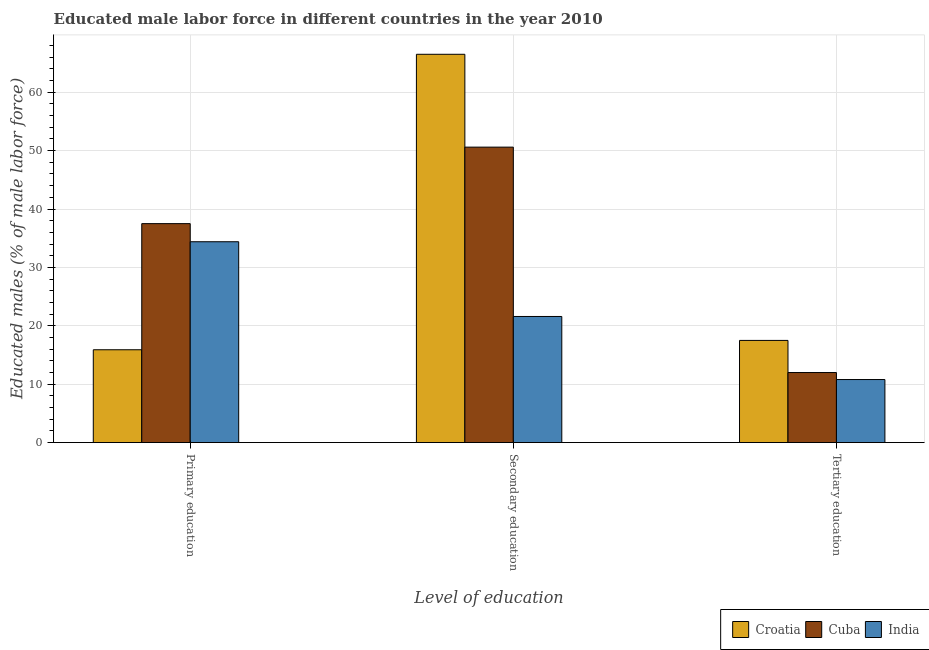How many different coloured bars are there?
Provide a short and direct response. 3. How many groups of bars are there?
Ensure brevity in your answer.  3. How many bars are there on the 2nd tick from the left?
Keep it short and to the point. 3. How many bars are there on the 3rd tick from the right?
Your answer should be compact. 3. What is the label of the 3rd group of bars from the left?
Offer a very short reply. Tertiary education. What is the percentage of male labor force who received secondary education in Cuba?
Offer a terse response. 50.6. Across all countries, what is the maximum percentage of male labor force who received secondary education?
Provide a short and direct response. 66.5. Across all countries, what is the minimum percentage of male labor force who received primary education?
Ensure brevity in your answer.  15.9. In which country was the percentage of male labor force who received tertiary education maximum?
Offer a very short reply. Croatia. In which country was the percentage of male labor force who received primary education minimum?
Your answer should be compact. Croatia. What is the total percentage of male labor force who received secondary education in the graph?
Give a very brief answer. 138.7. What is the difference between the percentage of male labor force who received secondary education in Croatia and that in Cuba?
Your response must be concise. 15.9. What is the difference between the percentage of male labor force who received primary education in India and the percentage of male labor force who received tertiary education in Croatia?
Your response must be concise. 16.9. What is the average percentage of male labor force who received primary education per country?
Make the answer very short. 29.27. What is the difference between the percentage of male labor force who received tertiary education and percentage of male labor force who received primary education in Cuba?
Offer a very short reply. -25.5. In how many countries, is the percentage of male labor force who received primary education greater than 24 %?
Offer a terse response. 2. What is the ratio of the percentage of male labor force who received secondary education in Croatia to that in India?
Your answer should be very brief. 3.08. Is the percentage of male labor force who received tertiary education in Croatia less than that in India?
Ensure brevity in your answer.  No. Is the difference between the percentage of male labor force who received secondary education in Cuba and India greater than the difference between the percentage of male labor force who received primary education in Cuba and India?
Make the answer very short. Yes. What is the difference between the highest and the second highest percentage of male labor force who received primary education?
Your answer should be very brief. 3.1. What is the difference between the highest and the lowest percentage of male labor force who received primary education?
Your answer should be compact. 21.6. Is the sum of the percentage of male labor force who received tertiary education in Cuba and India greater than the maximum percentage of male labor force who received primary education across all countries?
Offer a very short reply. No. What does the 2nd bar from the right in Primary education represents?
Provide a succinct answer. Cuba. How many bars are there?
Give a very brief answer. 9. What is the difference between two consecutive major ticks on the Y-axis?
Provide a succinct answer. 10. Does the graph contain grids?
Give a very brief answer. Yes. Where does the legend appear in the graph?
Give a very brief answer. Bottom right. How many legend labels are there?
Offer a very short reply. 3. How are the legend labels stacked?
Your answer should be very brief. Horizontal. What is the title of the graph?
Keep it short and to the point. Educated male labor force in different countries in the year 2010. What is the label or title of the X-axis?
Your response must be concise. Level of education. What is the label or title of the Y-axis?
Your answer should be very brief. Educated males (% of male labor force). What is the Educated males (% of male labor force) in Croatia in Primary education?
Give a very brief answer. 15.9. What is the Educated males (% of male labor force) in Cuba in Primary education?
Your response must be concise. 37.5. What is the Educated males (% of male labor force) of India in Primary education?
Your response must be concise. 34.4. What is the Educated males (% of male labor force) in Croatia in Secondary education?
Make the answer very short. 66.5. What is the Educated males (% of male labor force) in Cuba in Secondary education?
Provide a succinct answer. 50.6. What is the Educated males (% of male labor force) of India in Secondary education?
Provide a short and direct response. 21.6. What is the Educated males (% of male labor force) in India in Tertiary education?
Give a very brief answer. 10.8. Across all Level of education, what is the maximum Educated males (% of male labor force) of Croatia?
Your answer should be very brief. 66.5. Across all Level of education, what is the maximum Educated males (% of male labor force) in Cuba?
Make the answer very short. 50.6. Across all Level of education, what is the maximum Educated males (% of male labor force) in India?
Provide a succinct answer. 34.4. Across all Level of education, what is the minimum Educated males (% of male labor force) in Croatia?
Keep it short and to the point. 15.9. Across all Level of education, what is the minimum Educated males (% of male labor force) in Cuba?
Your answer should be very brief. 12. Across all Level of education, what is the minimum Educated males (% of male labor force) of India?
Keep it short and to the point. 10.8. What is the total Educated males (% of male labor force) of Croatia in the graph?
Your answer should be compact. 99.9. What is the total Educated males (% of male labor force) of Cuba in the graph?
Your answer should be very brief. 100.1. What is the total Educated males (% of male labor force) of India in the graph?
Your answer should be very brief. 66.8. What is the difference between the Educated males (% of male labor force) in Croatia in Primary education and that in Secondary education?
Make the answer very short. -50.6. What is the difference between the Educated males (% of male labor force) in Cuba in Primary education and that in Secondary education?
Provide a succinct answer. -13.1. What is the difference between the Educated males (% of male labor force) of Croatia in Primary education and that in Tertiary education?
Give a very brief answer. -1.6. What is the difference between the Educated males (% of male labor force) in India in Primary education and that in Tertiary education?
Offer a very short reply. 23.6. What is the difference between the Educated males (% of male labor force) in Cuba in Secondary education and that in Tertiary education?
Offer a very short reply. 38.6. What is the difference between the Educated males (% of male labor force) of Croatia in Primary education and the Educated males (% of male labor force) of Cuba in Secondary education?
Make the answer very short. -34.7. What is the difference between the Educated males (% of male labor force) in Croatia in Primary education and the Educated males (% of male labor force) in India in Tertiary education?
Offer a very short reply. 5.1. What is the difference between the Educated males (% of male labor force) in Cuba in Primary education and the Educated males (% of male labor force) in India in Tertiary education?
Give a very brief answer. 26.7. What is the difference between the Educated males (% of male labor force) of Croatia in Secondary education and the Educated males (% of male labor force) of Cuba in Tertiary education?
Offer a very short reply. 54.5. What is the difference between the Educated males (% of male labor force) of Croatia in Secondary education and the Educated males (% of male labor force) of India in Tertiary education?
Offer a terse response. 55.7. What is the difference between the Educated males (% of male labor force) of Cuba in Secondary education and the Educated males (% of male labor force) of India in Tertiary education?
Your answer should be compact. 39.8. What is the average Educated males (% of male labor force) of Croatia per Level of education?
Your answer should be very brief. 33.3. What is the average Educated males (% of male labor force) in Cuba per Level of education?
Make the answer very short. 33.37. What is the average Educated males (% of male labor force) in India per Level of education?
Your answer should be very brief. 22.27. What is the difference between the Educated males (% of male labor force) of Croatia and Educated males (% of male labor force) of Cuba in Primary education?
Your answer should be compact. -21.6. What is the difference between the Educated males (% of male labor force) of Croatia and Educated males (% of male labor force) of India in Primary education?
Your answer should be compact. -18.5. What is the difference between the Educated males (% of male labor force) of Cuba and Educated males (% of male labor force) of India in Primary education?
Your response must be concise. 3.1. What is the difference between the Educated males (% of male labor force) in Croatia and Educated males (% of male labor force) in India in Secondary education?
Your response must be concise. 44.9. What is the difference between the Educated males (% of male labor force) of Croatia and Educated males (% of male labor force) of India in Tertiary education?
Your answer should be compact. 6.7. What is the ratio of the Educated males (% of male labor force) of Croatia in Primary education to that in Secondary education?
Keep it short and to the point. 0.24. What is the ratio of the Educated males (% of male labor force) of Cuba in Primary education to that in Secondary education?
Your answer should be very brief. 0.74. What is the ratio of the Educated males (% of male labor force) of India in Primary education to that in Secondary education?
Your answer should be very brief. 1.59. What is the ratio of the Educated males (% of male labor force) of Croatia in Primary education to that in Tertiary education?
Your answer should be very brief. 0.91. What is the ratio of the Educated males (% of male labor force) in Cuba in Primary education to that in Tertiary education?
Make the answer very short. 3.12. What is the ratio of the Educated males (% of male labor force) in India in Primary education to that in Tertiary education?
Your response must be concise. 3.19. What is the ratio of the Educated males (% of male labor force) in Croatia in Secondary education to that in Tertiary education?
Ensure brevity in your answer.  3.8. What is the ratio of the Educated males (% of male labor force) of Cuba in Secondary education to that in Tertiary education?
Keep it short and to the point. 4.22. What is the difference between the highest and the second highest Educated males (% of male labor force) of Croatia?
Your answer should be compact. 49. What is the difference between the highest and the second highest Educated males (% of male labor force) in India?
Your answer should be very brief. 12.8. What is the difference between the highest and the lowest Educated males (% of male labor force) in Croatia?
Make the answer very short. 50.6. What is the difference between the highest and the lowest Educated males (% of male labor force) of Cuba?
Keep it short and to the point. 38.6. What is the difference between the highest and the lowest Educated males (% of male labor force) of India?
Offer a terse response. 23.6. 